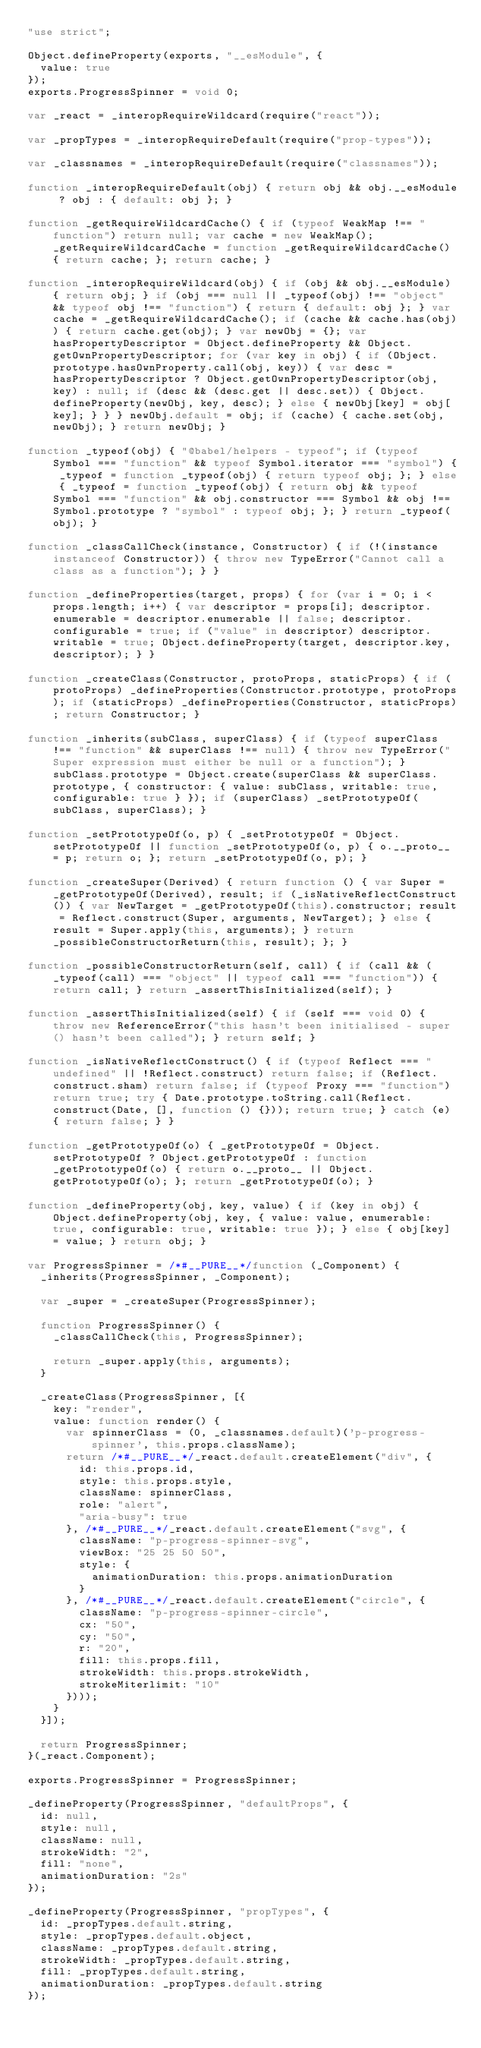<code> <loc_0><loc_0><loc_500><loc_500><_JavaScript_>"use strict";

Object.defineProperty(exports, "__esModule", {
  value: true
});
exports.ProgressSpinner = void 0;

var _react = _interopRequireWildcard(require("react"));

var _propTypes = _interopRequireDefault(require("prop-types"));

var _classnames = _interopRequireDefault(require("classnames"));

function _interopRequireDefault(obj) { return obj && obj.__esModule ? obj : { default: obj }; }

function _getRequireWildcardCache() { if (typeof WeakMap !== "function") return null; var cache = new WeakMap(); _getRequireWildcardCache = function _getRequireWildcardCache() { return cache; }; return cache; }

function _interopRequireWildcard(obj) { if (obj && obj.__esModule) { return obj; } if (obj === null || _typeof(obj) !== "object" && typeof obj !== "function") { return { default: obj }; } var cache = _getRequireWildcardCache(); if (cache && cache.has(obj)) { return cache.get(obj); } var newObj = {}; var hasPropertyDescriptor = Object.defineProperty && Object.getOwnPropertyDescriptor; for (var key in obj) { if (Object.prototype.hasOwnProperty.call(obj, key)) { var desc = hasPropertyDescriptor ? Object.getOwnPropertyDescriptor(obj, key) : null; if (desc && (desc.get || desc.set)) { Object.defineProperty(newObj, key, desc); } else { newObj[key] = obj[key]; } } } newObj.default = obj; if (cache) { cache.set(obj, newObj); } return newObj; }

function _typeof(obj) { "@babel/helpers - typeof"; if (typeof Symbol === "function" && typeof Symbol.iterator === "symbol") { _typeof = function _typeof(obj) { return typeof obj; }; } else { _typeof = function _typeof(obj) { return obj && typeof Symbol === "function" && obj.constructor === Symbol && obj !== Symbol.prototype ? "symbol" : typeof obj; }; } return _typeof(obj); }

function _classCallCheck(instance, Constructor) { if (!(instance instanceof Constructor)) { throw new TypeError("Cannot call a class as a function"); } }

function _defineProperties(target, props) { for (var i = 0; i < props.length; i++) { var descriptor = props[i]; descriptor.enumerable = descriptor.enumerable || false; descriptor.configurable = true; if ("value" in descriptor) descriptor.writable = true; Object.defineProperty(target, descriptor.key, descriptor); } }

function _createClass(Constructor, protoProps, staticProps) { if (protoProps) _defineProperties(Constructor.prototype, protoProps); if (staticProps) _defineProperties(Constructor, staticProps); return Constructor; }

function _inherits(subClass, superClass) { if (typeof superClass !== "function" && superClass !== null) { throw new TypeError("Super expression must either be null or a function"); } subClass.prototype = Object.create(superClass && superClass.prototype, { constructor: { value: subClass, writable: true, configurable: true } }); if (superClass) _setPrototypeOf(subClass, superClass); }

function _setPrototypeOf(o, p) { _setPrototypeOf = Object.setPrototypeOf || function _setPrototypeOf(o, p) { o.__proto__ = p; return o; }; return _setPrototypeOf(o, p); }

function _createSuper(Derived) { return function () { var Super = _getPrototypeOf(Derived), result; if (_isNativeReflectConstruct()) { var NewTarget = _getPrototypeOf(this).constructor; result = Reflect.construct(Super, arguments, NewTarget); } else { result = Super.apply(this, arguments); } return _possibleConstructorReturn(this, result); }; }

function _possibleConstructorReturn(self, call) { if (call && (_typeof(call) === "object" || typeof call === "function")) { return call; } return _assertThisInitialized(self); }

function _assertThisInitialized(self) { if (self === void 0) { throw new ReferenceError("this hasn't been initialised - super() hasn't been called"); } return self; }

function _isNativeReflectConstruct() { if (typeof Reflect === "undefined" || !Reflect.construct) return false; if (Reflect.construct.sham) return false; if (typeof Proxy === "function") return true; try { Date.prototype.toString.call(Reflect.construct(Date, [], function () {})); return true; } catch (e) { return false; } }

function _getPrototypeOf(o) { _getPrototypeOf = Object.setPrototypeOf ? Object.getPrototypeOf : function _getPrototypeOf(o) { return o.__proto__ || Object.getPrototypeOf(o); }; return _getPrototypeOf(o); }

function _defineProperty(obj, key, value) { if (key in obj) { Object.defineProperty(obj, key, { value: value, enumerable: true, configurable: true, writable: true }); } else { obj[key] = value; } return obj; }

var ProgressSpinner = /*#__PURE__*/function (_Component) {
  _inherits(ProgressSpinner, _Component);

  var _super = _createSuper(ProgressSpinner);

  function ProgressSpinner() {
    _classCallCheck(this, ProgressSpinner);

    return _super.apply(this, arguments);
  }

  _createClass(ProgressSpinner, [{
    key: "render",
    value: function render() {
      var spinnerClass = (0, _classnames.default)('p-progress-spinner', this.props.className);
      return /*#__PURE__*/_react.default.createElement("div", {
        id: this.props.id,
        style: this.props.style,
        className: spinnerClass,
        role: "alert",
        "aria-busy": true
      }, /*#__PURE__*/_react.default.createElement("svg", {
        className: "p-progress-spinner-svg",
        viewBox: "25 25 50 50",
        style: {
          animationDuration: this.props.animationDuration
        }
      }, /*#__PURE__*/_react.default.createElement("circle", {
        className: "p-progress-spinner-circle",
        cx: "50",
        cy: "50",
        r: "20",
        fill: this.props.fill,
        strokeWidth: this.props.strokeWidth,
        strokeMiterlimit: "10"
      })));
    }
  }]);

  return ProgressSpinner;
}(_react.Component);

exports.ProgressSpinner = ProgressSpinner;

_defineProperty(ProgressSpinner, "defaultProps", {
  id: null,
  style: null,
  className: null,
  strokeWidth: "2",
  fill: "none",
  animationDuration: "2s"
});

_defineProperty(ProgressSpinner, "propTypes", {
  id: _propTypes.default.string,
  style: _propTypes.default.object,
  className: _propTypes.default.string,
  strokeWidth: _propTypes.default.string,
  fill: _propTypes.default.string,
  animationDuration: _propTypes.default.string
});</code> 